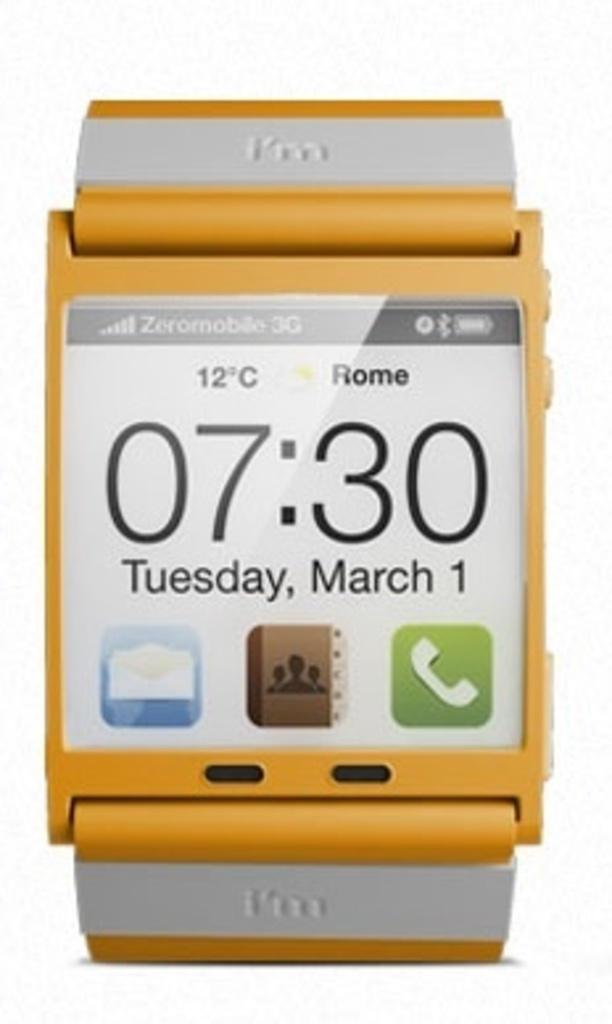<image>
Give a short and clear explanation of the subsequent image. watch which displays the time of 7:30 tuesday march 1st 